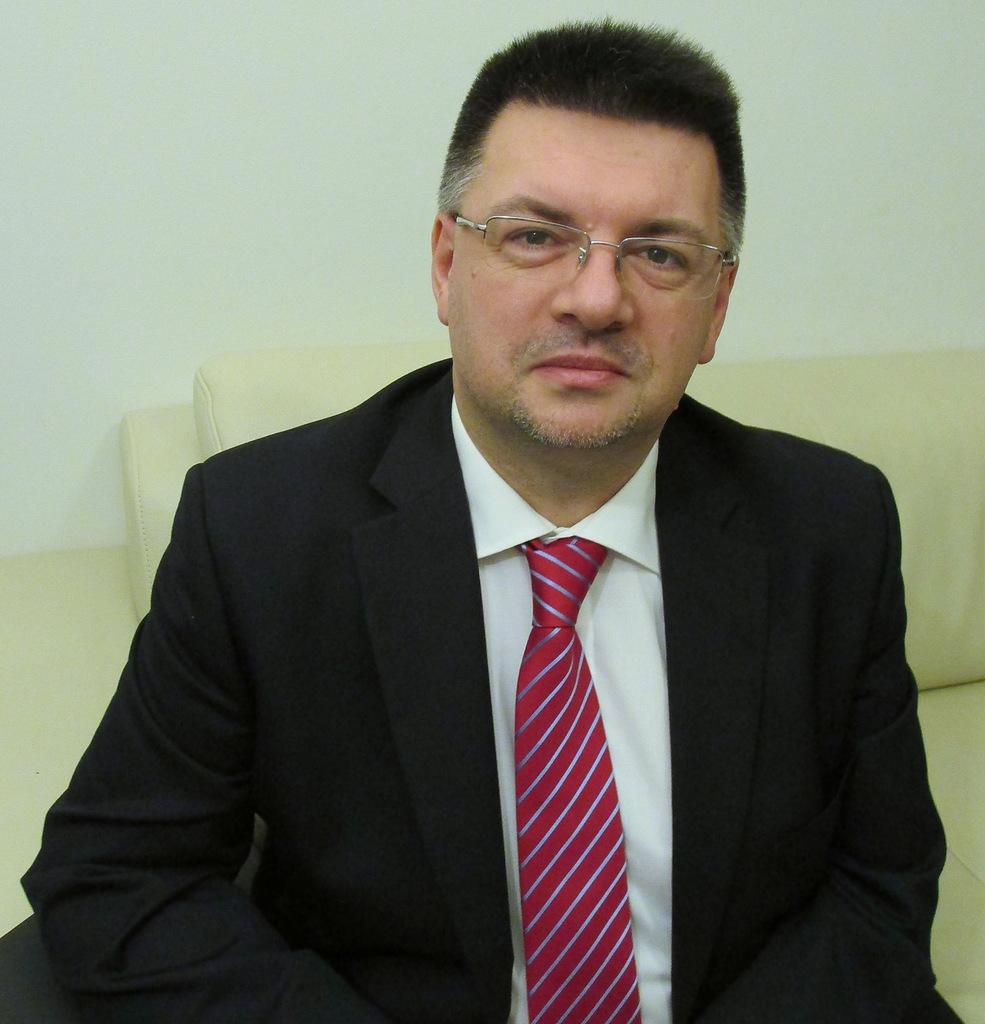Who is present in the image? There is a man in the image. What is the man doing in the image? The man is sitting on a sofa. What is the man wearing in the image? The man is wearing a suit and spectacles. What can be seen in the background of the image? There is a wall in the background of the image. What type of quiver is the man holding in the image? There is no quiver present in the image; the man is wearing a suit and sitting on a sofa. 